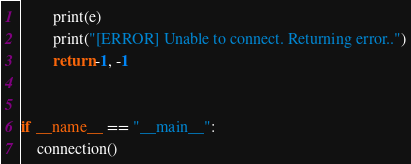Convert code to text. <code><loc_0><loc_0><loc_500><loc_500><_Python_>        print(e)
        print("[ERROR] Unable to connect. Returning error..")
        return -1, -1


if __name__ == "__main__":
    connection()
</code> 